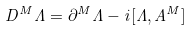<formula> <loc_0><loc_0><loc_500><loc_500>D ^ { M } \Lambda = \partial ^ { M } \Lambda - i [ \Lambda , A ^ { M } ]</formula> 